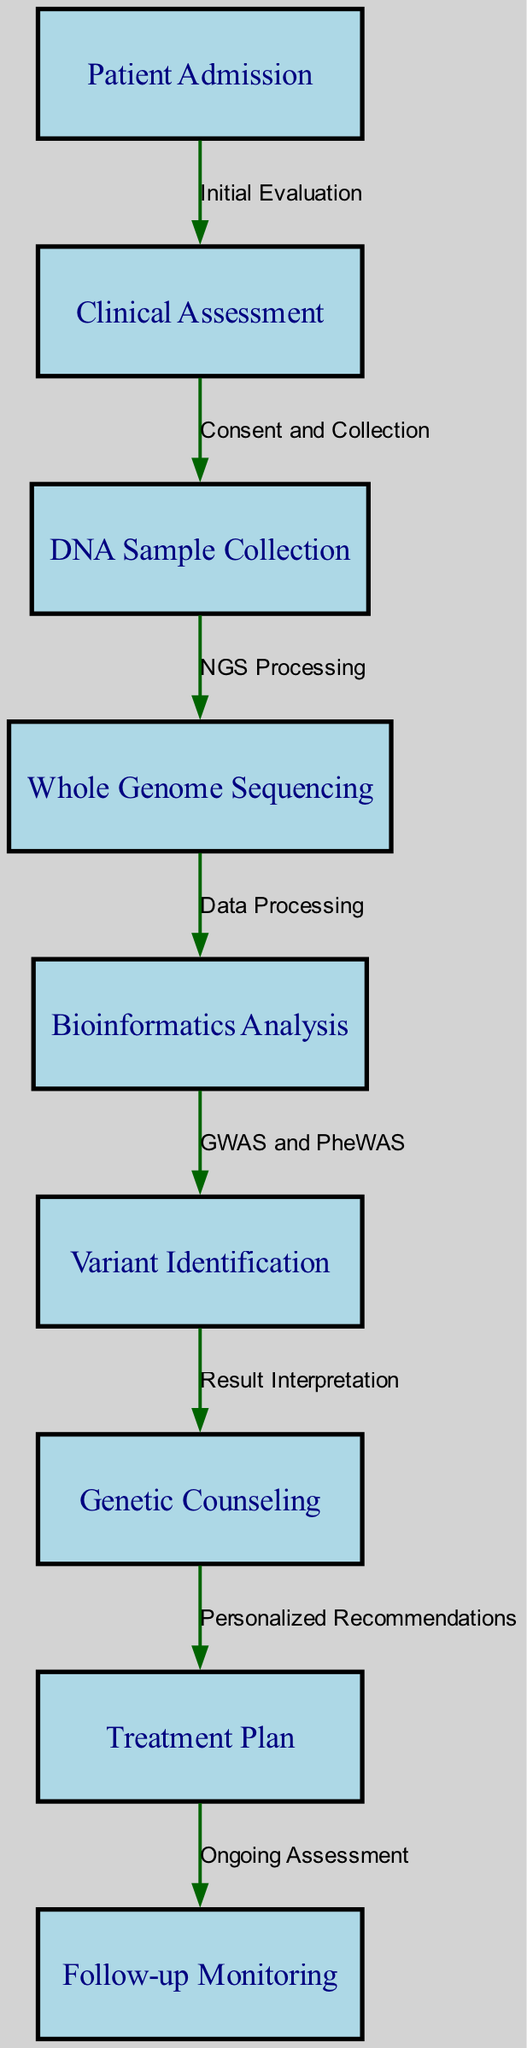What is the first step in the clinical pathway? The clinical pathway begins with "Patient Admission" as the first node, indicating the starting point of the process.
Answer: Patient Admission How many nodes are in the clinical pathway? Counting all distinct nodes listed in the diagram (from Patient Admission to Follow-up Monitoring), there are a total of 9 nodes.
Answer: 9 What is the label of the last node in the clinical pathway? The last node in the pathway is "Follow-up Monitoring," which indicates the final step of the process.
Answer: Follow-up Monitoring What process occurs after DNA sample collection? Following DNA Sample Collection, the next step in the pathway is "Whole Genome Sequencing," which processes the collected samples.
Answer: Whole Genome Sequencing What action is taken after variant identification? After Variant Identification, "Genetic Counseling" takes place, providing guidance to the patient based on their genetic results.
Answer: Genetic Counseling How many edges are present in the clinical pathway? By counting the connections between nodes in the diagram, we find there are 8 edges that represent the flow from one step to the next.
Answer: 8 What is the relationship between clinical assessment and DNA sample collection? The relationship is established through "Consent and Collection," which indicates that the clinical assessment leads to obtaining consent for DNA sampling.
Answer: Consent and Collection What is the action taken after genetic counseling? The action taken after Genetic Counseling is the formulation of a "Treatment Plan," which is personalized based on the genetic insights.
Answer: Treatment Plan What type of analysis is performed after whole genome sequencing? After Whole Genome Sequencing, "Bioinformatics Analysis" is conducted to process the sequencing data and identify potential variants.
Answer: Bioinformatics Analysis 